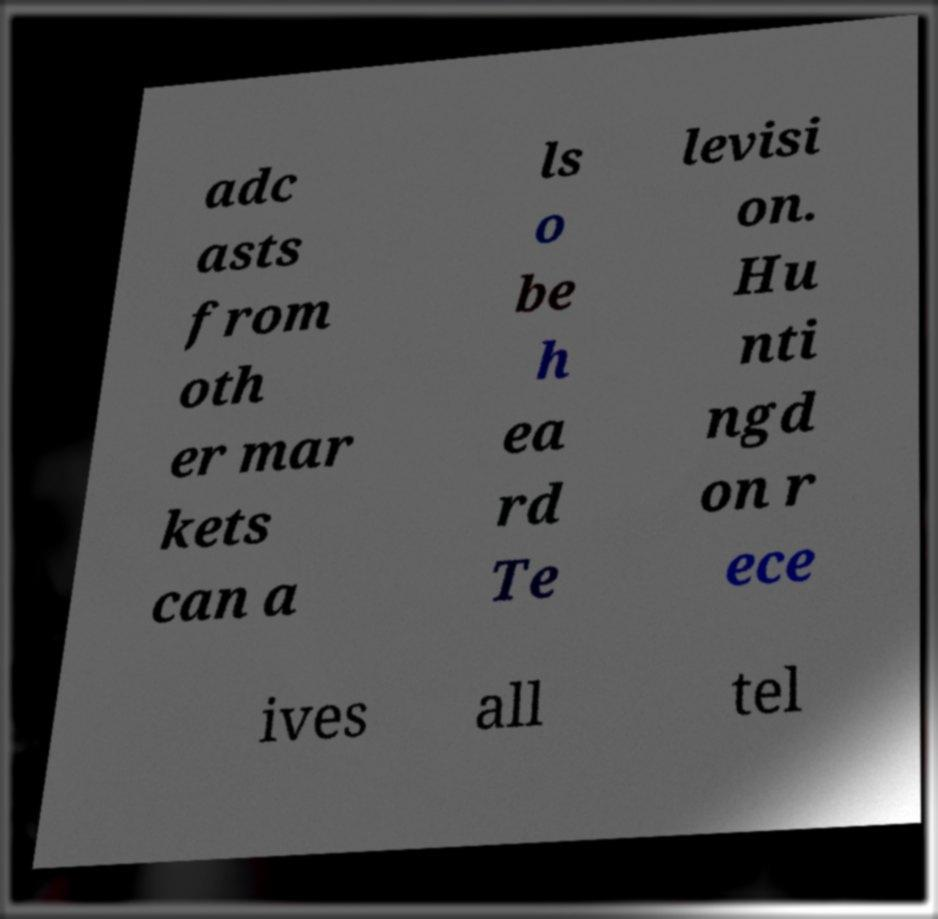For documentation purposes, I need the text within this image transcribed. Could you provide that? adc asts from oth er mar kets can a ls o be h ea rd Te levisi on. Hu nti ngd on r ece ives all tel 